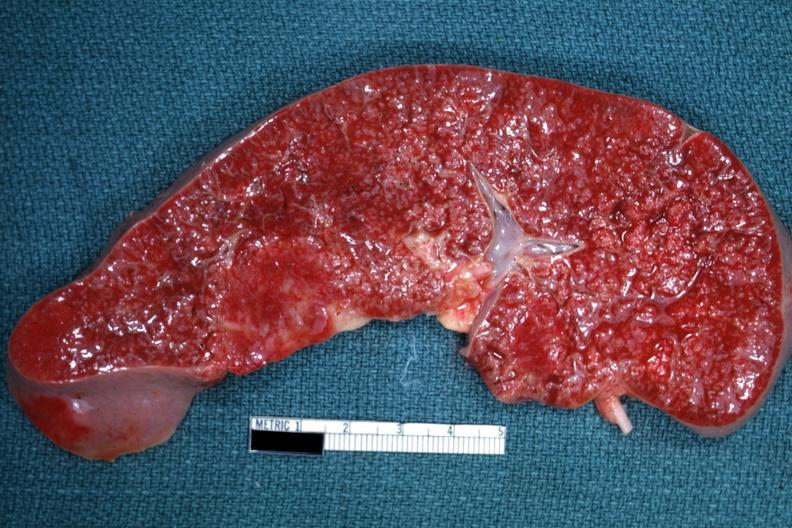what is present?
Answer the question using a single word or phrase. Malignant lymphoma 